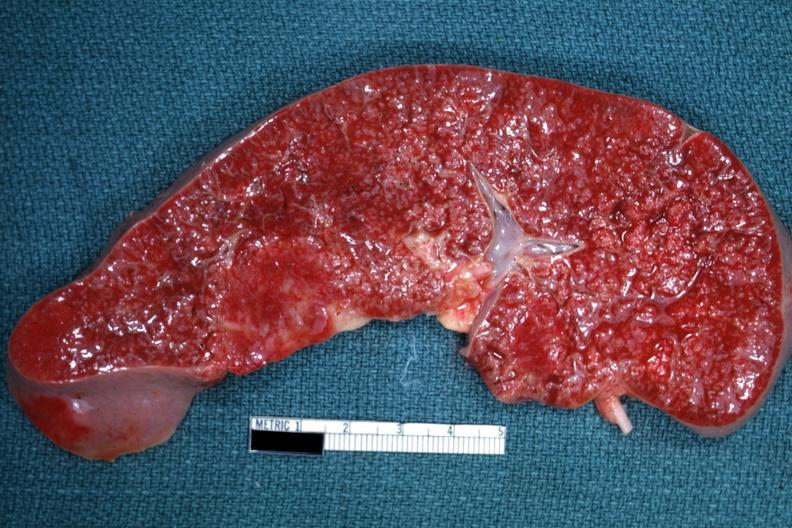what is present?
Answer the question using a single word or phrase. Malignant lymphoma 